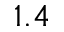<formula> <loc_0><loc_0><loc_500><loc_500>1 . 4</formula> 